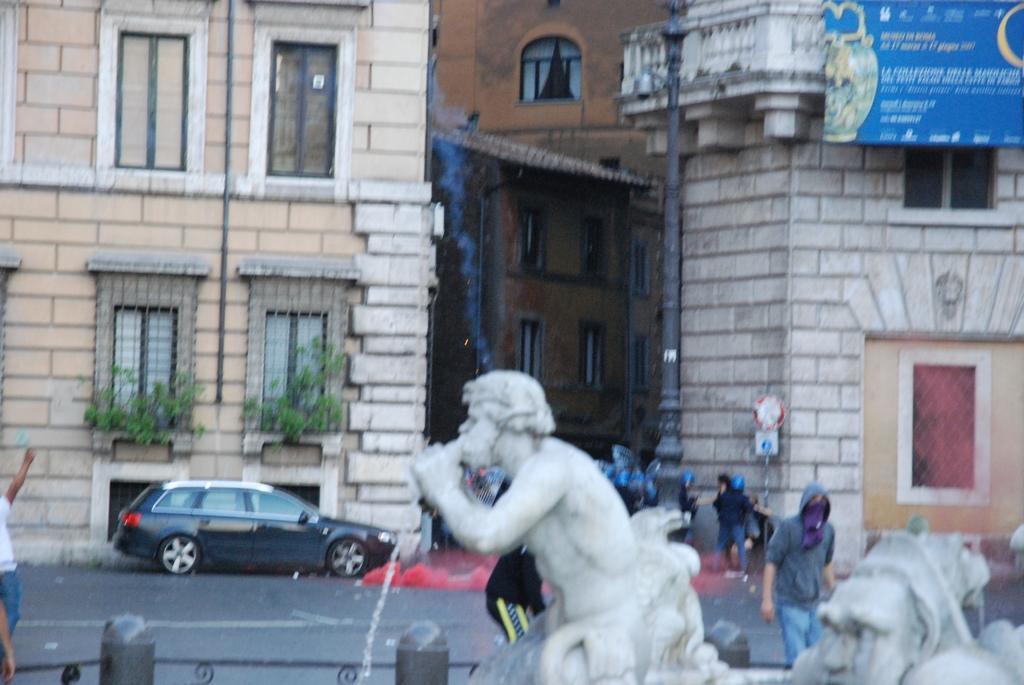Can you describe this image briefly? In this image I can see few sculptures, few people, a building, windows, few plants, few people, a board and a car. 